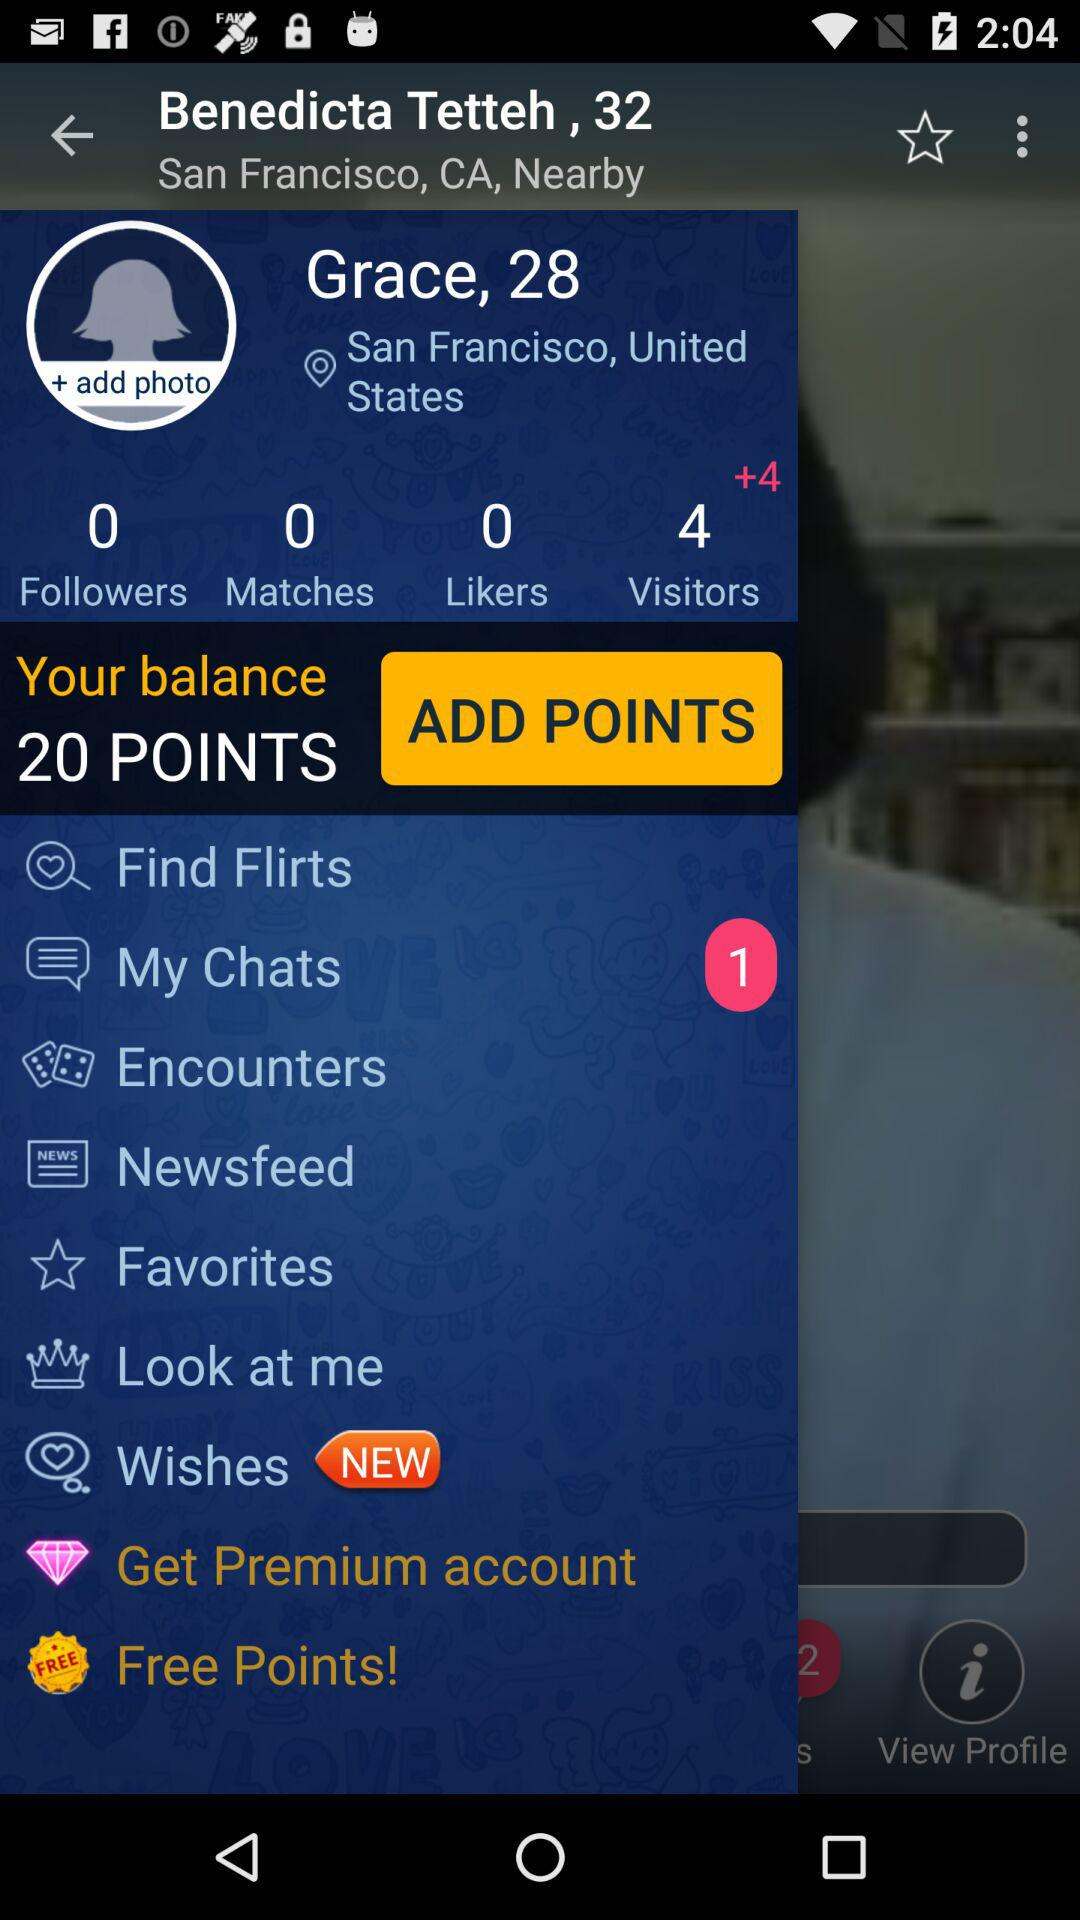How many unread chats are there? There is 1 unread chat. 